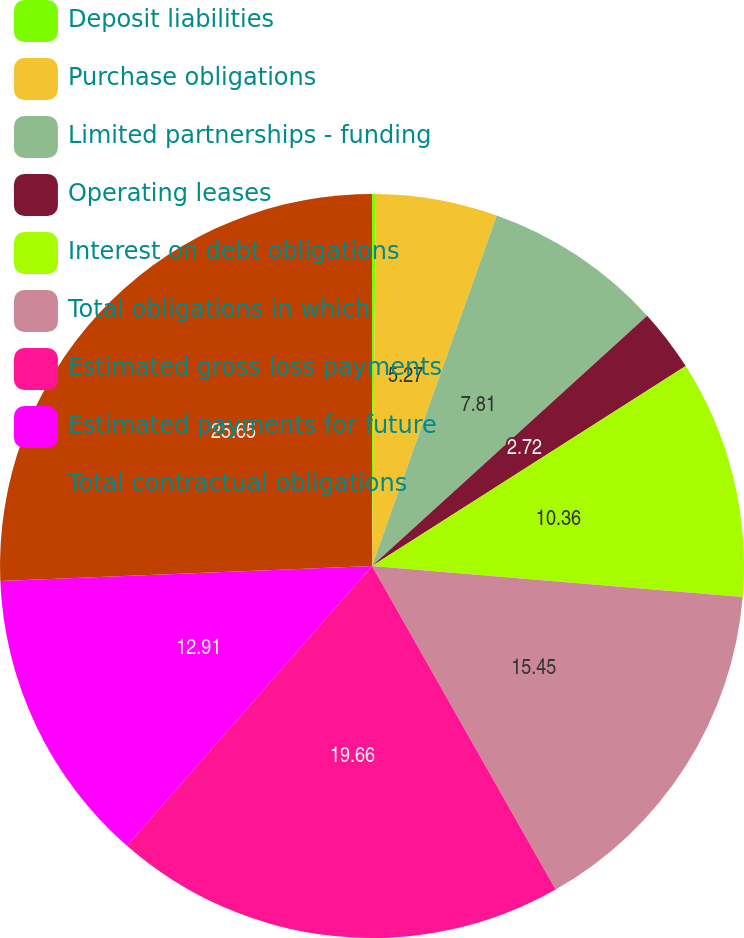<chart> <loc_0><loc_0><loc_500><loc_500><pie_chart><fcel>Deposit liabilities<fcel>Purchase obligations<fcel>Limited partnerships - funding<fcel>Operating leases<fcel>Interest on debt obligations<fcel>Total obligations in which<fcel>Estimated gross loss payments<fcel>Estimated payments for future<fcel>Total contractual obligations<nl><fcel>0.17%<fcel>5.27%<fcel>7.81%<fcel>2.72%<fcel>10.36%<fcel>15.45%<fcel>19.66%<fcel>12.91%<fcel>25.64%<nl></chart> 